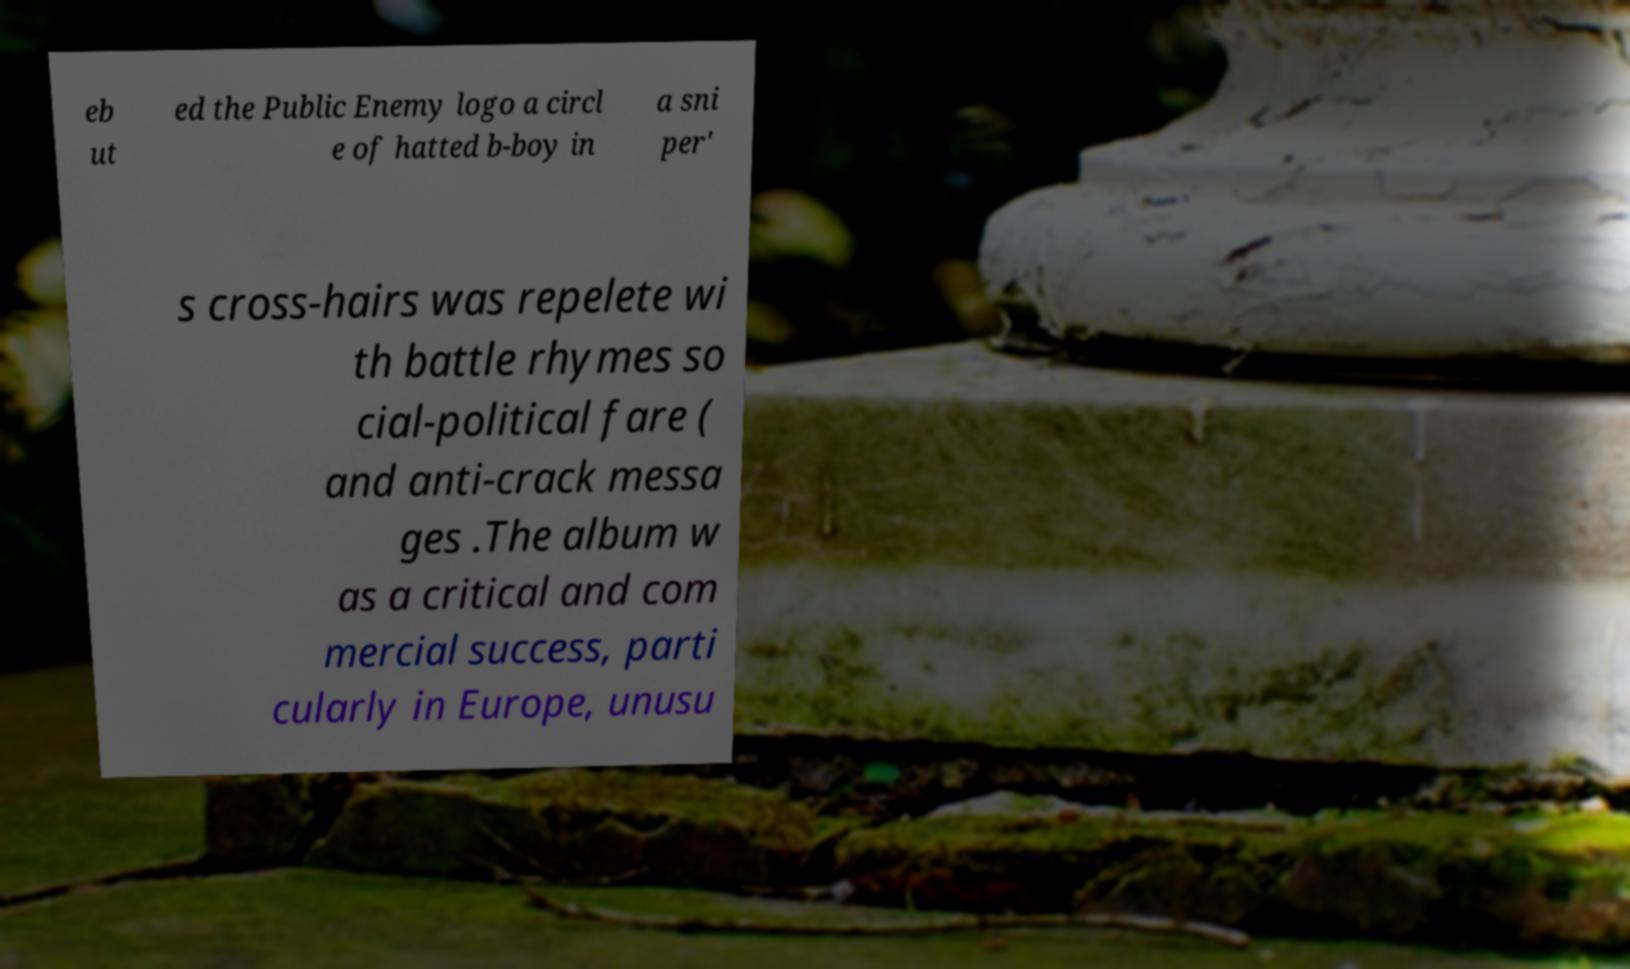What messages or text are displayed in this image? I need them in a readable, typed format. eb ut ed the Public Enemy logo a circl e of hatted b-boy in a sni per' s cross-hairs was repelete wi th battle rhymes so cial-political fare ( and anti-crack messa ges .The album w as a critical and com mercial success, parti cularly in Europe, unusu 